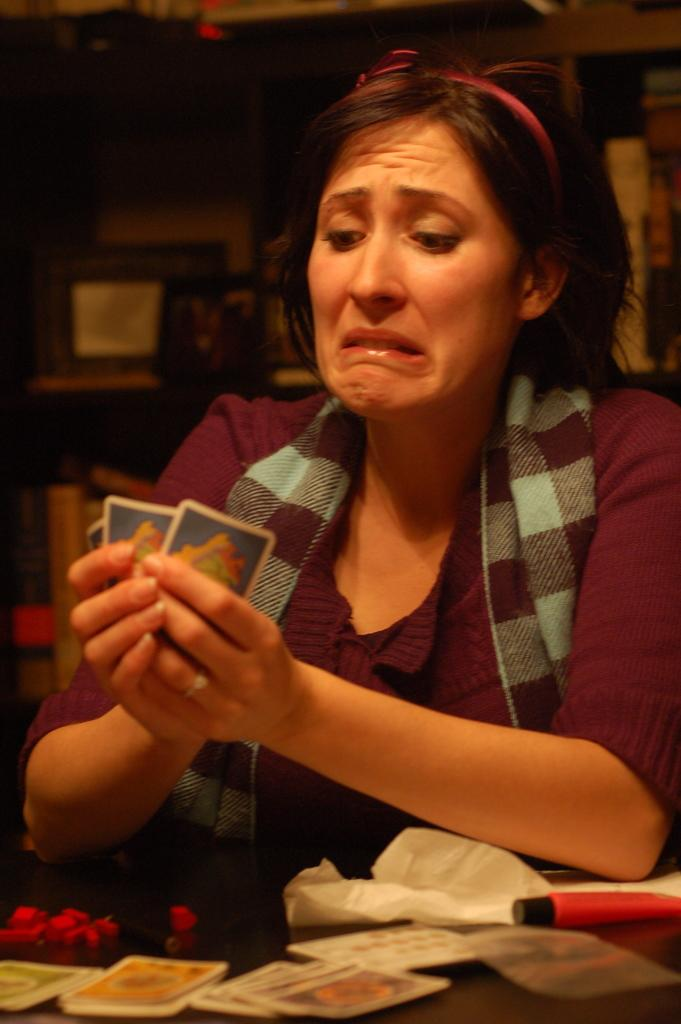Who is the main subject in the image? There is a woman in the image. What is the woman holding in the image? The woman is holding cards. Can you describe the cards in front of the woman? There are cards visible in front of the woman. What else can be seen on the table in the image? There are objects on the table. What can be seen in the background of the image? There are objects visible in the background of the image. Can you see a team of ants carrying the cards on the seashore in the image? There is no team of ants or seashore present in the image; it features a woman holding cards and objects on a table. 